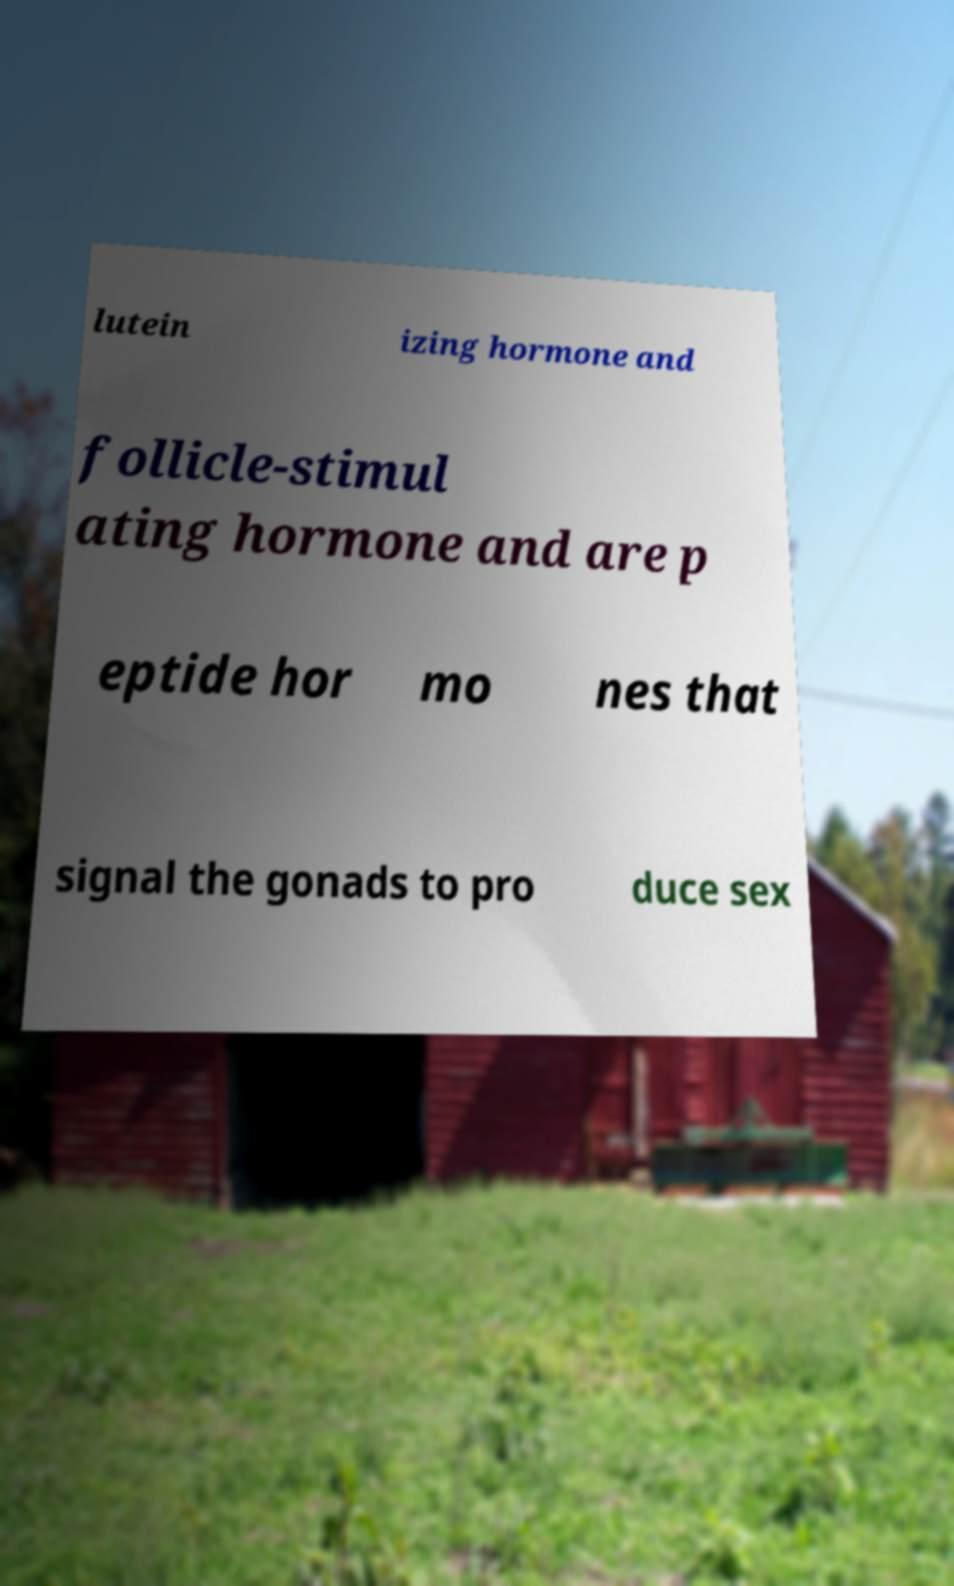I need the written content from this picture converted into text. Can you do that? lutein izing hormone and follicle-stimul ating hormone and are p eptide hor mo nes that signal the gonads to pro duce sex 